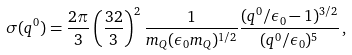<formula> <loc_0><loc_0><loc_500><loc_500>\sigma ( q ^ { 0 } ) = \frac { 2 \pi } { 3 } \left ( \frac { 3 2 } { 3 } \right ) ^ { 2 } \frac { 1 } { m _ { Q } ( \epsilon _ { 0 } m _ { Q } ) ^ { 1 / 2 } } \frac { ( q ^ { 0 } / \epsilon _ { 0 } - 1 ) ^ { 3 / 2 } } { ( q ^ { 0 } / \epsilon _ { 0 } ) ^ { 5 } } \, ,</formula> 